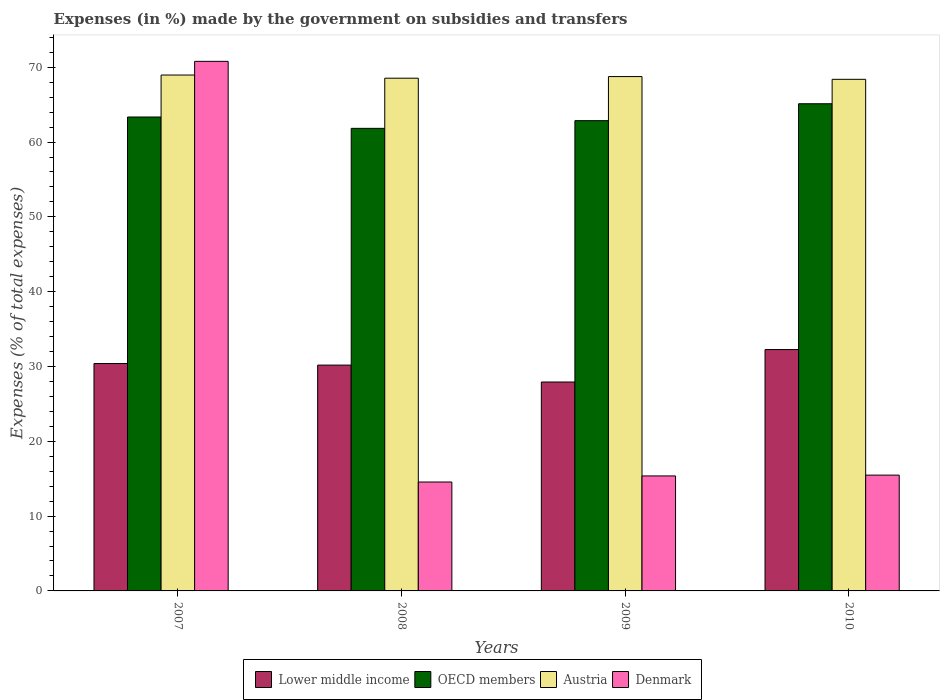How many groups of bars are there?
Provide a short and direct response. 4. Are the number of bars per tick equal to the number of legend labels?
Keep it short and to the point. Yes. How many bars are there on the 4th tick from the left?
Your answer should be compact. 4. How many bars are there on the 3rd tick from the right?
Your answer should be very brief. 4. In how many cases, is the number of bars for a given year not equal to the number of legend labels?
Offer a terse response. 0. What is the percentage of expenses made by the government on subsidies and transfers in OECD members in 2010?
Offer a very short reply. 65.12. Across all years, what is the maximum percentage of expenses made by the government on subsidies and transfers in Austria?
Keep it short and to the point. 68.96. Across all years, what is the minimum percentage of expenses made by the government on subsidies and transfers in Denmark?
Your answer should be very brief. 14.56. What is the total percentage of expenses made by the government on subsidies and transfers in Lower middle income in the graph?
Make the answer very short. 120.77. What is the difference between the percentage of expenses made by the government on subsidies and transfers in OECD members in 2008 and that in 2009?
Make the answer very short. -1.03. What is the difference between the percentage of expenses made by the government on subsidies and transfers in Lower middle income in 2007 and the percentage of expenses made by the government on subsidies and transfers in Denmark in 2010?
Provide a short and direct response. 14.91. What is the average percentage of expenses made by the government on subsidies and transfers in Denmark per year?
Offer a very short reply. 29.05. In the year 2007, what is the difference between the percentage of expenses made by the government on subsidies and transfers in OECD members and percentage of expenses made by the government on subsidies and transfers in Lower middle income?
Keep it short and to the point. 32.95. What is the ratio of the percentage of expenses made by the government on subsidies and transfers in OECD members in 2009 to that in 2010?
Offer a very short reply. 0.97. Is the percentage of expenses made by the government on subsidies and transfers in Austria in 2008 less than that in 2010?
Keep it short and to the point. No. Is the difference between the percentage of expenses made by the government on subsidies and transfers in OECD members in 2007 and 2008 greater than the difference between the percentage of expenses made by the government on subsidies and transfers in Lower middle income in 2007 and 2008?
Your answer should be very brief. Yes. What is the difference between the highest and the second highest percentage of expenses made by the government on subsidies and transfers in OECD members?
Your answer should be compact. 1.77. What is the difference between the highest and the lowest percentage of expenses made by the government on subsidies and transfers in Lower middle income?
Your response must be concise. 4.34. In how many years, is the percentage of expenses made by the government on subsidies and transfers in Lower middle income greater than the average percentage of expenses made by the government on subsidies and transfers in Lower middle income taken over all years?
Your response must be concise. 2. Is the sum of the percentage of expenses made by the government on subsidies and transfers in Austria in 2008 and 2009 greater than the maximum percentage of expenses made by the government on subsidies and transfers in Denmark across all years?
Your response must be concise. Yes. What does the 3rd bar from the right in 2010 represents?
Ensure brevity in your answer.  OECD members. Is it the case that in every year, the sum of the percentage of expenses made by the government on subsidies and transfers in Austria and percentage of expenses made by the government on subsidies and transfers in OECD members is greater than the percentage of expenses made by the government on subsidies and transfers in Denmark?
Offer a very short reply. Yes. Are all the bars in the graph horizontal?
Offer a terse response. No. Are the values on the major ticks of Y-axis written in scientific E-notation?
Your response must be concise. No. Does the graph contain any zero values?
Provide a short and direct response. No. What is the title of the graph?
Keep it short and to the point. Expenses (in %) made by the government on subsidies and transfers. What is the label or title of the X-axis?
Your answer should be very brief. Years. What is the label or title of the Y-axis?
Ensure brevity in your answer.  Expenses (% of total expenses). What is the Expenses (% of total expenses) of Lower middle income in 2007?
Provide a short and direct response. 30.39. What is the Expenses (% of total expenses) in OECD members in 2007?
Offer a very short reply. 63.35. What is the Expenses (% of total expenses) of Austria in 2007?
Keep it short and to the point. 68.96. What is the Expenses (% of total expenses) of Denmark in 2007?
Ensure brevity in your answer.  70.79. What is the Expenses (% of total expenses) in Lower middle income in 2008?
Provide a succinct answer. 30.18. What is the Expenses (% of total expenses) of OECD members in 2008?
Keep it short and to the point. 61.83. What is the Expenses (% of total expenses) of Austria in 2008?
Offer a terse response. 68.53. What is the Expenses (% of total expenses) in Denmark in 2008?
Your answer should be compact. 14.56. What is the Expenses (% of total expenses) of Lower middle income in 2009?
Provide a short and direct response. 27.92. What is the Expenses (% of total expenses) of OECD members in 2009?
Keep it short and to the point. 62.86. What is the Expenses (% of total expenses) of Austria in 2009?
Keep it short and to the point. 68.75. What is the Expenses (% of total expenses) in Denmark in 2009?
Offer a very short reply. 15.37. What is the Expenses (% of total expenses) of Lower middle income in 2010?
Offer a terse response. 32.26. What is the Expenses (% of total expenses) in OECD members in 2010?
Keep it short and to the point. 65.12. What is the Expenses (% of total expenses) of Austria in 2010?
Give a very brief answer. 68.38. What is the Expenses (% of total expenses) in Denmark in 2010?
Ensure brevity in your answer.  15.48. Across all years, what is the maximum Expenses (% of total expenses) of Lower middle income?
Offer a very short reply. 32.26. Across all years, what is the maximum Expenses (% of total expenses) of OECD members?
Provide a short and direct response. 65.12. Across all years, what is the maximum Expenses (% of total expenses) in Austria?
Offer a very short reply. 68.96. Across all years, what is the maximum Expenses (% of total expenses) of Denmark?
Give a very brief answer. 70.79. Across all years, what is the minimum Expenses (% of total expenses) of Lower middle income?
Offer a very short reply. 27.92. Across all years, what is the minimum Expenses (% of total expenses) in OECD members?
Give a very brief answer. 61.83. Across all years, what is the minimum Expenses (% of total expenses) in Austria?
Provide a succinct answer. 68.38. Across all years, what is the minimum Expenses (% of total expenses) in Denmark?
Your answer should be very brief. 14.56. What is the total Expenses (% of total expenses) in Lower middle income in the graph?
Provide a short and direct response. 120.77. What is the total Expenses (% of total expenses) in OECD members in the graph?
Make the answer very short. 253.15. What is the total Expenses (% of total expenses) in Austria in the graph?
Provide a succinct answer. 274.63. What is the total Expenses (% of total expenses) of Denmark in the graph?
Provide a succinct answer. 116.19. What is the difference between the Expenses (% of total expenses) in Lower middle income in 2007 and that in 2008?
Offer a terse response. 0.21. What is the difference between the Expenses (% of total expenses) of OECD members in 2007 and that in 2008?
Keep it short and to the point. 1.52. What is the difference between the Expenses (% of total expenses) of Austria in 2007 and that in 2008?
Keep it short and to the point. 0.42. What is the difference between the Expenses (% of total expenses) of Denmark in 2007 and that in 2008?
Offer a very short reply. 56.23. What is the difference between the Expenses (% of total expenses) in Lower middle income in 2007 and that in 2009?
Provide a succinct answer. 2.47. What is the difference between the Expenses (% of total expenses) in OECD members in 2007 and that in 2009?
Your answer should be very brief. 0.49. What is the difference between the Expenses (% of total expenses) of Austria in 2007 and that in 2009?
Your answer should be compact. 0.21. What is the difference between the Expenses (% of total expenses) in Denmark in 2007 and that in 2009?
Offer a very short reply. 55.41. What is the difference between the Expenses (% of total expenses) in Lower middle income in 2007 and that in 2010?
Your answer should be very brief. -1.87. What is the difference between the Expenses (% of total expenses) in OECD members in 2007 and that in 2010?
Your answer should be very brief. -1.77. What is the difference between the Expenses (% of total expenses) in Austria in 2007 and that in 2010?
Provide a short and direct response. 0.57. What is the difference between the Expenses (% of total expenses) in Denmark in 2007 and that in 2010?
Make the answer very short. 55.31. What is the difference between the Expenses (% of total expenses) of Lower middle income in 2008 and that in 2009?
Give a very brief answer. 2.26. What is the difference between the Expenses (% of total expenses) of OECD members in 2008 and that in 2009?
Ensure brevity in your answer.  -1.03. What is the difference between the Expenses (% of total expenses) of Austria in 2008 and that in 2009?
Ensure brevity in your answer.  -0.22. What is the difference between the Expenses (% of total expenses) in Denmark in 2008 and that in 2009?
Your answer should be very brief. -0.81. What is the difference between the Expenses (% of total expenses) in Lower middle income in 2008 and that in 2010?
Give a very brief answer. -2.08. What is the difference between the Expenses (% of total expenses) of OECD members in 2008 and that in 2010?
Your answer should be compact. -3.29. What is the difference between the Expenses (% of total expenses) in Austria in 2008 and that in 2010?
Provide a succinct answer. 0.15. What is the difference between the Expenses (% of total expenses) in Denmark in 2008 and that in 2010?
Your response must be concise. -0.92. What is the difference between the Expenses (% of total expenses) of Lower middle income in 2009 and that in 2010?
Your answer should be compact. -4.34. What is the difference between the Expenses (% of total expenses) of OECD members in 2009 and that in 2010?
Your response must be concise. -2.26. What is the difference between the Expenses (% of total expenses) in Austria in 2009 and that in 2010?
Offer a very short reply. 0.37. What is the difference between the Expenses (% of total expenses) in Denmark in 2009 and that in 2010?
Your answer should be compact. -0.11. What is the difference between the Expenses (% of total expenses) in Lower middle income in 2007 and the Expenses (% of total expenses) in OECD members in 2008?
Offer a very short reply. -31.43. What is the difference between the Expenses (% of total expenses) of Lower middle income in 2007 and the Expenses (% of total expenses) of Austria in 2008?
Your answer should be compact. -38.14. What is the difference between the Expenses (% of total expenses) of Lower middle income in 2007 and the Expenses (% of total expenses) of Denmark in 2008?
Your response must be concise. 15.84. What is the difference between the Expenses (% of total expenses) in OECD members in 2007 and the Expenses (% of total expenses) in Austria in 2008?
Provide a succinct answer. -5.19. What is the difference between the Expenses (% of total expenses) in OECD members in 2007 and the Expenses (% of total expenses) in Denmark in 2008?
Keep it short and to the point. 48.79. What is the difference between the Expenses (% of total expenses) in Austria in 2007 and the Expenses (% of total expenses) in Denmark in 2008?
Your answer should be very brief. 54.4. What is the difference between the Expenses (% of total expenses) in Lower middle income in 2007 and the Expenses (% of total expenses) in OECD members in 2009?
Give a very brief answer. -32.46. What is the difference between the Expenses (% of total expenses) of Lower middle income in 2007 and the Expenses (% of total expenses) of Austria in 2009?
Offer a terse response. -38.36. What is the difference between the Expenses (% of total expenses) of Lower middle income in 2007 and the Expenses (% of total expenses) of Denmark in 2009?
Keep it short and to the point. 15.02. What is the difference between the Expenses (% of total expenses) of OECD members in 2007 and the Expenses (% of total expenses) of Austria in 2009?
Give a very brief answer. -5.41. What is the difference between the Expenses (% of total expenses) of OECD members in 2007 and the Expenses (% of total expenses) of Denmark in 2009?
Offer a terse response. 47.97. What is the difference between the Expenses (% of total expenses) of Austria in 2007 and the Expenses (% of total expenses) of Denmark in 2009?
Make the answer very short. 53.59. What is the difference between the Expenses (% of total expenses) of Lower middle income in 2007 and the Expenses (% of total expenses) of OECD members in 2010?
Provide a succinct answer. -34.72. What is the difference between the Expenses (% of total expenses) in Lower middle income in 2007 and the Expenses (% of total expenses) in Austria in 2010?
Ensure brevity in your answer.  -37.99. What is the difference between the Expenses (% of total expenses) of Lower middle income in 2007 and the Expenses (% of total expenses) of Denmark in 2010?
Your answer should be very brief. 14.91. What is the difference between the Expenses (% of total expenses) of OECD members in 2007 and the Expenses (% of total expenses) of Austria in 2010?
Give a very brief answer. -5.04. What is the difference between the Expenses (% of total expenses) of OECD members in 2007 and the Expenses (% of total expenses) of Denmark in 2010?
Your answer should be compact. 47.87. What is the difference between the Expenses (% of total expenses) of Austria in 2007 and the Expenses (% of total expenses) of Denmark in 2010?
Offer a very short reply. 53.48. What is the difference between the Expenses (% of total expenses) in Lower middle income in 2008 and the Expenses (% of total expenses) in OECD members in 2009?
Give a very brief answer. -32.67. What is the difference between the Expenses (% of total expenses) of Lower middle income in 2008 and the Expenses (% of total expenses) of Austria in 2009?
Provide a succinct answer. -38.57. What is the difference between the Expenses (% of total expenses) in Lower middle income in 2008 and the Expenses (% of total expenses) in Denmark in 2009?
Offer a very short reply. 14.81. What is the difference between the Expenses (% of total expenses) in OECD members in 2008 and the Expenses (% of total expenses) in Austria in 2009?
Provide a succinct answer. -6.92. What is the difference between the Expenses (% of total expenses) in OECD members in 2008 and the Expenses (% of total expenses) in Denmark in 2009?
Make the answer very short. 46.46. What is the difference between the Expenses (% of total expenses) in Austria in 2008 and the Expenses (% of total expenses) in Denmark in 2009?
Give a very brief answer. 53.16. What is the difference between the Expenses (% of total expenses) of Lower middle income in 2008 and the Expenses (% of total expenses) of OECD members in 2010?
Give a very brief answer. -34.93. What is the difference between the Expenses (% of total expenses) of Lower middle income in 2008 and the Expenses (% of total expenses) of Austria in 2010?
Your answer should be very brief. -38.2. What is the difference between the Expenses (% of total expenses) of Lower middle income in 2008 and the Expenses (% of total expenses) of Denmark in 2010?
Keep it short and to the point. 14.7. What is the difference between the Expenses (% of total expenses) of OECD members in 2008 and the Expenses (% of total expenses) of Austria in 2010?
Your response must be concise. -6.55. What is the difference between the Expenses (% of total expenses) of OECD members in 2008 and the Expenses (% of total expenses) of Denmark in 2010?
Offer a very short reply. 46.35. What is the difference between the Expenses (% of total expenses) of Austria in 2008 and the Expenses (% of total expenses) of Denmark in 2010?
Give a very brief answer. 53.06. What is the difference between the Expenses (% of total expenses) in Lower middle income in 2009 and the Expenses (% of total expenses) in OECD members in 2010?
Your response must be concise. -37.19. What is the difference between the Expenses (% of total expenses) in Lower middle income in 2009 and the Expenses (% of total expenses) in Austria in 2010?
Your answer should be very brief. -40.46. What is the difference between the Expenses (% of total expenses) in Lower middle income in 2009 and the Expenses (% of total expenses) in Denmark in 2010?
Give a very brief answer. 12.45. What is the difference between the Expenses (% of total expenses) of OECD members in 2009 and the Expenses (% of total expenses) of Austria in 2010?
Offer a very short reply. -5.53. What is the difference between the Expenses (% of total expenses) of OECD members in 2009 and the Expenses (% of total expenses) of Denmark in 2010?
Your answer should be very brief. 47.38. What is the difference between the Expenses (% of total expenses) in Austria in 2009 and the Expenses (% of total expenses) in Denmark in 2010?
Your answer should be compact. 53.27. What is the average Expenses (% of total expenses) in Lower middle income per year?
Ensure brevity in your answer.  30.19. What is the average Expenses (% of total expenses) of OECD members per year?
Provide a succinct answer. 63.29. What is the average Expenses (% of total expenses) of Austria per year?
Offer a terse response. 68.66. What is the average Expenses (% of total expenses) of Denmark per year?
Provide a short and direct response. 29.05. In the year 2007, what is the difference between the Expenses (% of total expenses) in Lower middle income and Expenses (% of total expenses) in OECD members?
Your response must be concise. -32.95. In the year 2007, what is the difference between the Expenses (% of total expenses) of Lower middle income and Expenses (% of total expenses) of Austria?
Your answer should be compact. -38.56. In the year 2007, what is the difference between the Expenses (% of total expenses) in Lower middle income and Expenses (% of total expenses) in Denmark?
Provide a short and direct response. -40.39. In the year 2007, what is the difference between the Expenses (% of total expenses) in OECD members and Expenses (% of total expenses) in Austria?
Your answer should be very brief. -5.61. In the year 2007, what is the difference between the Expenses (% of total expenses) in OECD members and Expenses (% of total expenses) in Denmark?
Offer a very short reply. -7.44. In the year 2007, what is the difference between the Expenses (% of total expenses) in Austria and Expenses (% of total expenses) in Denmark?
Keep it short and to the point. -1.83. In the year 2008, what is the difference between the Expenses (% of total expenses) in Lower middle income and Expenses (% of total expenses) in OECD members?
Offer a terse response. -31.64. In the year 2008, what is the difference between the Expenses (% of total expenses) of Lower middle income and Expenses (% of total expenses) of Austria?
Keep it short and to the point. -38.35. In the year 2008, what is the difference between the Expenses (% of total expenses) of Lower middle income and Expenses (% of total expenses) of Denmark?
Make the answer very short. 15.63. In the year 2008, what is the difference between the Expenses (% of total expenses) in OECD members and Expenses (% of total expenses) in Austria?
Offer a very short reply. -6.71. In the year 2008, what is the difference between the Expenses (% of total expenses) of OECD members and Expenses (% of total expenses) of Denmark?
Your answer should be compact. 47.27. In the year 2008, what is the difference between the Expenses (% of total expenses) of Austria and Expenses (% of total expenses) of Denmark?
Your answer should be compact. 53.98. In the year 2009, what is the difference between the Expenses (% of total expenses) in Lower middle income and Expenses (% of total expenses) in OECD members?
Make the answer very short. -34.93. In the year 2009, what is the difference between the Expenses (% of total expenses) of Lower middle income and Expenses (% of total expenses) of Austria?
Provide a succinct answer. -40.83. In the year 2009, what is the difference between the Expenses (% of total expenses) in Lower middle income and Expenses (% of total expenses) in Denmark?
Provide a short and direct response. 12.55. In the year 2009, what is the difference between the Expenses (% of total expenses) in OECD members and Expenses (% of total expenses) in Austria?
Your response must be concise. -5.89. In the year 2009, what is the difference between the Expenses (% of total expenses) of OECD members and Expenses (% of total expenses) of Denmark?
Provide a succinct answer. 47.49. In the year 2009, what is the difference between the Expenses (% of total expenses) of Austria and Expenses (% of total expenses) of Denmark?
Offer a terse response. 53.38. In the year 2010, what is the difference between the Expenses (% of total expenses) of Lower middle income and Expenses (% of total expenses) of OECD members?
Make the answer very short. -32.85. In the year 2010, what is the difference between the Expenses (% of total expenses) of Lower middle income and Expenses (% of total expenses) of Austria?
Your answer should be very brief. -36.12. In the year 2010, what is the difference between the Expenses (% of total expenses) in Lower middle income and Expenses (% of total expenses) in Denmark?
Your answer should be very brief. 16.78. In the year 2010, what is the difference between the Expenses (% of total expenses) in OECD members and Expenses (% of total expenses) in Austria?
Make the answer very short. -3.26. In the year 2010, what is the difference between the Expenses (% of total expenses) of OECD members and Expenses (% of total expenses) of Denmark?
Give a very brief answer. 49.64. In the year 2010, what is the difference between the Expenses (% of total expenses) in Austria and Expenses (% of total expenses) in Denmark?
Keep it short and to the point. 52.9. What is the ratio of the Expenses (% of total expenses) of OECD members in 2007 to that in 2008?
Your answer should be very brief. 1.02. What is the ratio of the Expenses (% of total expenses) in Denmark in 2007 to that in 2008?
Offer a very short reply. 4.86. What is the ratio of the Expenses (% of total expenses) of Lower middle income in 2007 to that in 2009?
Ensure brevity in your answer.  1.09. What is the ratio of the Expenses (% of total expenses) of OECD members in 2007 to that in 2009?
Your answer should be very brief. 1.01. What is the ratio of the Expenses (% of total expenses) in Denmark in 2007 to that in 2009?
Your response must be concise. 4.61. What is the ratio of the Expenses (% of total expenses) of Lower middle income in 2007 to that in 2010?
Your answer should be compact. 0.94. What is the ratio of the Expenses (% of total expenses) in OECD members in 2007 to that in 2010?
Offer a terse response. 0.97. What is the ratio of the Expenses (% of total expenses) of Austria in 2007 to that in 2010?
Your answer should be compact. 1.01. What is the ratio of the Expenses (% of total expenses) in Denmark in 2007 to that in 2010?
Your answer should be very brief. 4.57. What is the ratio of the Expenses (% of total expenses) of Lower middle income in 2008 to that in 2009?
Your answer should be very brief. 1.08. What is the ratio of the Expenses (% of total expenses) in OECD members in 2008 to that in 2009?
Provide a short and direct response. 0.98. What is the ratio of the Expenses (% of total expenses) in Austria in 2008 to that in 2009?
Provide a short and direct response. 1. What is the ratio of the Expenses (% of total expenses) in Denmark in 2008 to that in 2009?
Give a very brief answer. 0.95. What is the ratio of the Expenses (% of total expenses) in Lower middle income in 2008 to that in 2010?
Your answer should be very brief. 0.94. What is the ratio of the Expenses (% of total expenses) in OECD members in 2008 to that in 2010?
Keep it short and to the point. 0.95. What is the ratio of the Expenses (% of total expenses) in Austria in 2008 to that in 2010?
Your answer should be very brief. 1. What is the ratio of the Expenses (% of total expenses) of Denmark in 2008 to that in 2010?
Your answer should be compact. 0.94. What is the ratio of the Expenses (% of total expenses) of Lower middle income in 2009 to that in 2010?
Give a very brief answer. 0.87. What is the ratio of the Expenses (% of total expenses) of OECD members in 2009 to that in 2010?
Your answer should be very brief. 0.97. What is the ratio of the Expenses (% of total expenses) in Austria in 2009 to that in 2010?
Your answer should be compact. 1.01. What is the difference between the highest and the second highest Expenses (% of total expenses) in Lower middle income?
Ensure brevity in your answer.  1.87. What is the difference between the highest and the second highest Expenses (% of total expenses) of OECD members?
Provide a short and direct response. 1.77. What is the difference between the highest and the second highest Expenses (% of total expenses) in Austria?
Your response must be concise. 0.21. What is the difference between the highest and the second highest Expenses (% of total expenses) in Denmark?
Your answer should be very brief. 55.31. What is the difference between the highest and the lowest Expenses (% of total expenses) of Lower middle income?
Your answer should be very brief. 4.34. What is the difference between the highest and the lowest Expenses (% of total expenses) in OECD members?
Your answer should be compact. 3.29. What is the difference between the highest and the lowest Expenses (% of total expenses) in Austria?
Keep it short and to the point. 0.57. What is the difference between the highest and the lowest Expenses (% of total expenses) in Denmark?
Make the answer very short. 56.23. 